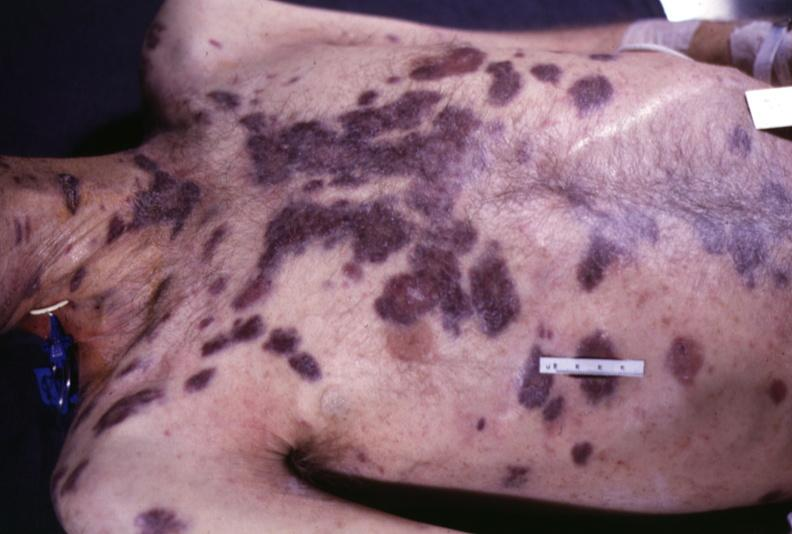what does this image show?
Answer the question using a single word or phrase. Skin 